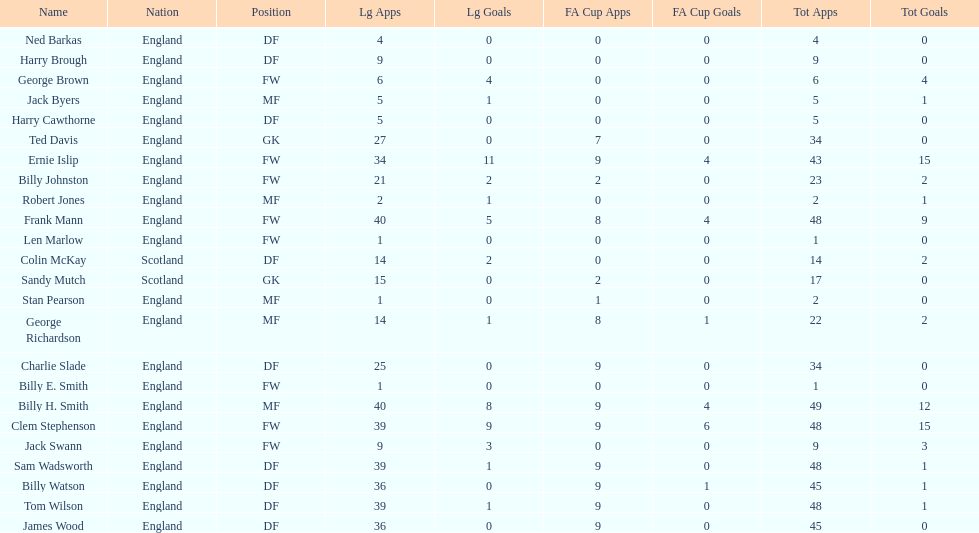What are the number of league apps ted davis has? 27. 